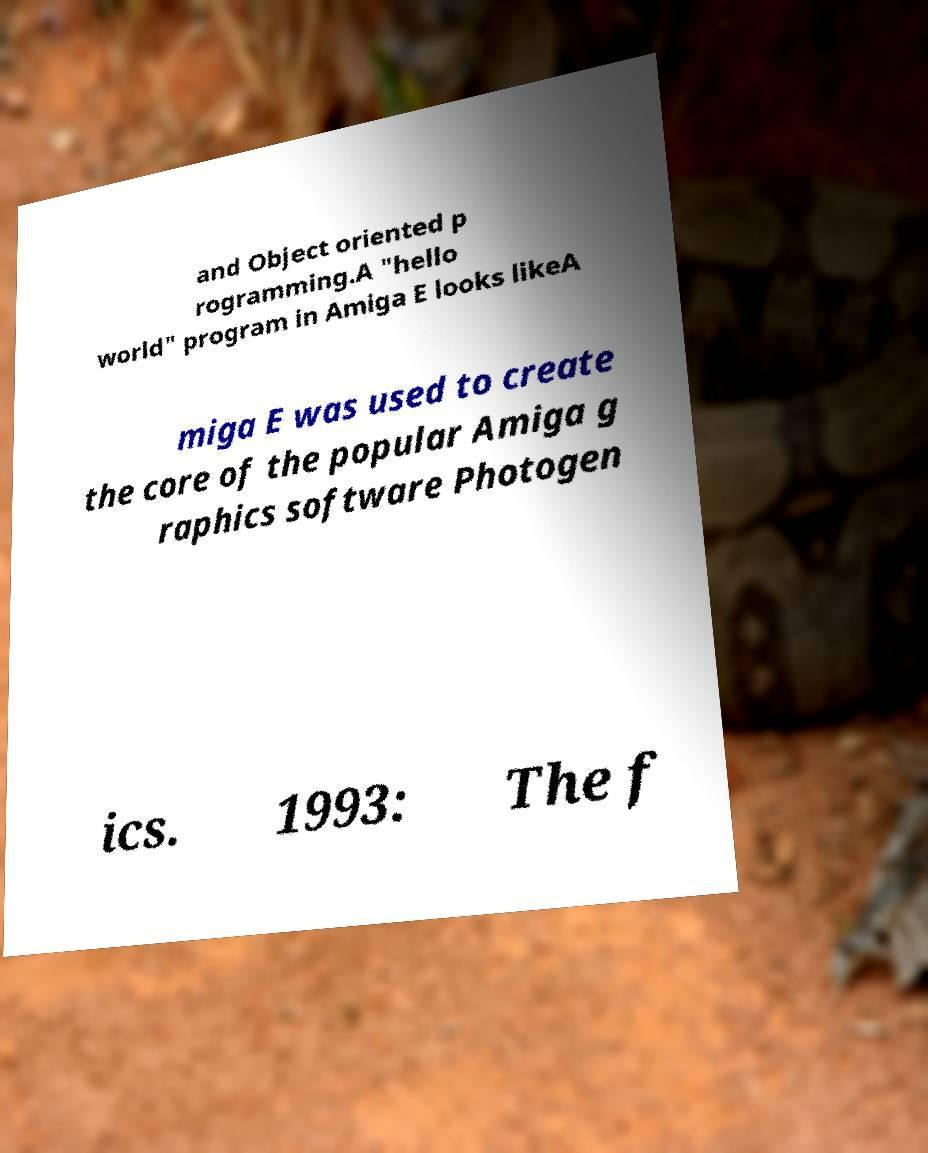For documentation purposes, I need the text within this image transcribed. Could you provide that? and Object oriented p rogramming.A "hello world" program in Amiga E looks likeA miga E was used to create the core of the popular Amiga g raphics software Photogen ics. 1993: The f 